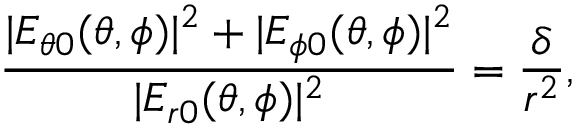Convert formula to latex. <formula><loc_0><loc_0><loc_500><loc_500>\frac { | E _ { \theta 0 } ( \theta , \phi ) | ^ { 2 } + | E _ { \phi 0 } ( \theta , \phi ) | ^ { 2 } } { | E _ { r 0 } ( \theta , \phi ) | ^ { 2 } } = \frac { \delta } { r ^ { 2 } } ,</formula> 